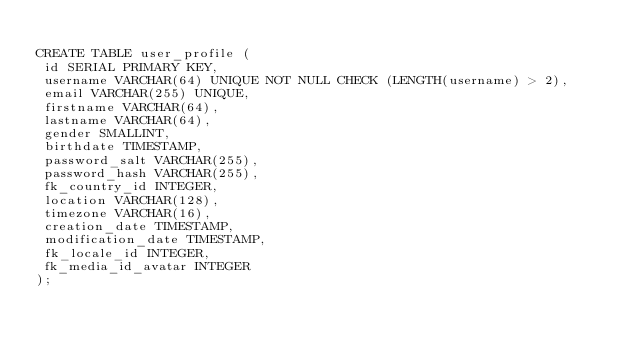Convert code to text. <code><loc_0><loc_0><loc_500><loc_500><_SQL_>
CREATE TABLE user_profile (
 id SERIAL PRIMARY KEY,
 username VARCHAR(64) UNIQUE NOT NULL CHECK (LENGTH(username) > 2),
 email VARCHAR(255) UNIQUE,
 firstname VARCHAR(64),
 lastname VARCHAR(64),
 gender SMALLINT,
 birthdate TIMESTAMP,
 password_salt VARCHAR(255),
 password_hash VARCHAR(255),
 fk_country_id INTEGER,
 location VARCHAR(128),
 timezone VARCHAR(16),
 creation_date TIMESTAMP,
 modification_date TIMESTAMP,
 fk_locale_id INTEGER,
 fk_media_id_avatar INTEGER
);
</code> 